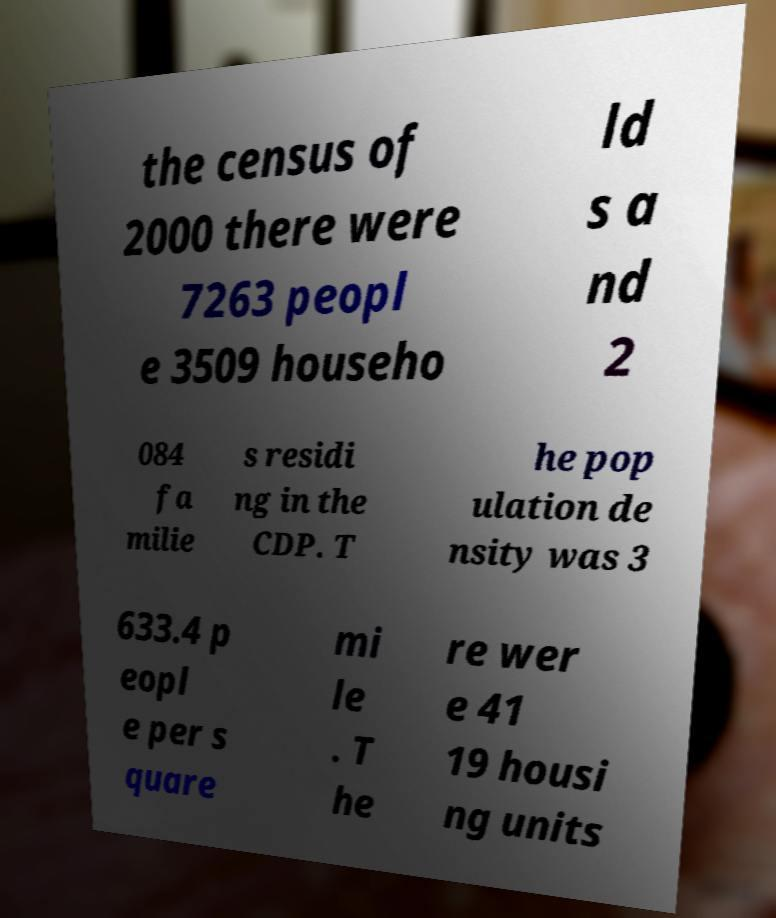Please identify and transcribe the text found in this image. the census of 2000 there were 7263 peopl e 3509 househo ld s a nd 2 084 fa milie s residi ng in the CDP. T he pop ulation de nsity was 3 633.4 p eopl e per s quare mi le . T he re wer e 41 19 housi ng units 